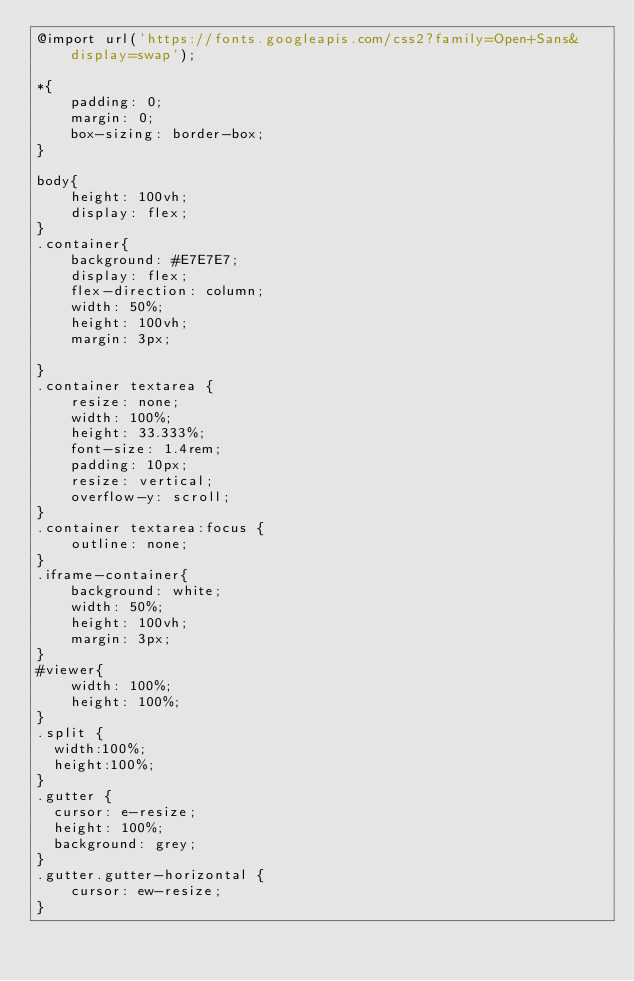<code> <loc_0><loc_0><loc_500><loc_500><_CSS_>@import url('https://fonts.googleapis.com/css2?family=Open+Sans&display=swap');

*{
	padding: 0;
	margin: 0;
	box-sizing: border-box;
}

body{
	height: 100vh;
	display: flex;
}
.container{
	background: #E7E7E7;
	display: flex;
	flex-direction: column;
	width: 50%;
	height: 100vh;
	margin: 3px;

}
.container textarea {
	resize: none;
	width: 100%;
	height: 33.333%;
	font-size: 1.4rem;
	padding: 10px;
	resize: vertical;
	overflow-y: scroll;
}
.container textarea:focus {
	outline: none;
}
.iframe-container{
	background: white;
	width: 50%;
	height: 100vh;
	margin: 3px;
}
#viewer{
	width: 100%;
	height: 100%;
}
.split {
  width:100%;
  height:100%;
}
.gutter {
  cursor: e-resize;
  height: 100%;
  background: grey;
}
.gutter.gutter-horizontal {
    cursor: ew-resize;
}
</code> 